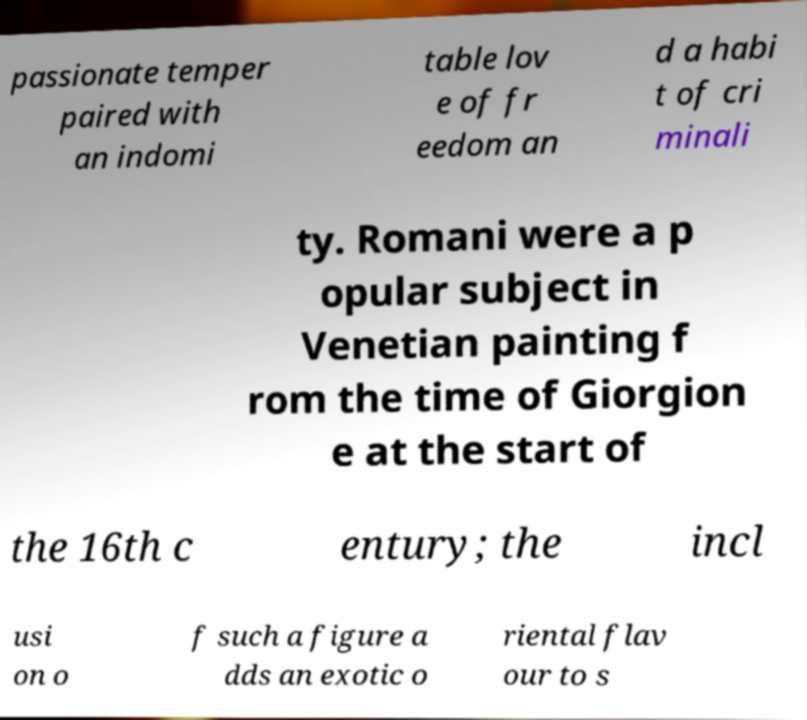Can you read and provide the text displayed in the image?This photo seems to have some interesting text. Can you extract and type it out for me? passionate temper paired with an indomi table lov e of fr eedom an d a habi t of cri minali ty. Romani were a p opular subject in Venetian painting f rom the time of Giorgion e at the start of the 16th c entury; the incl usi on o f such a figure a dds an exotic o riental flav our to s 